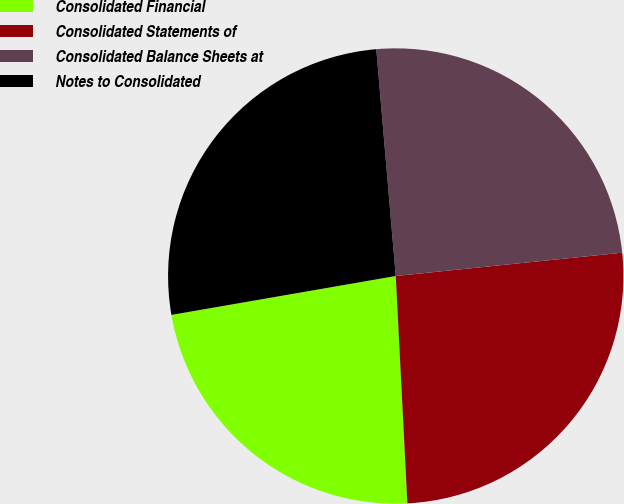Convert chart to OTSL. <chart><loc_0><loc_0><loc_500><loc_500><pie_chart><fcel>Consolidated Financial<fcel>Consolidated Statements of<fcel>Consolidated Balance Sheets at<fcel>Notes to Consolidated<nl><fcel>23.08%<fcel>25.82%<fcel>24.73%<fcel>26.37%<nl></chart> 